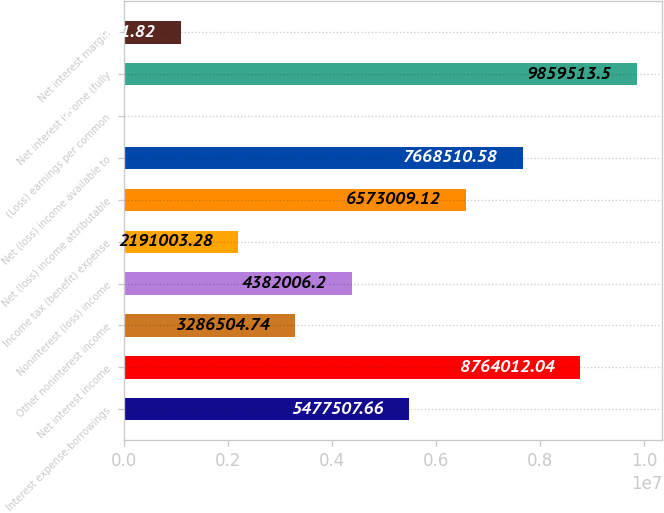<chart> <loc_0><loc_0><loc_500><loc_500><bar_chart><fcel>Interest expense-borrowings<fcel>Net interest income<fcel>Other noninterest income<fcel>Noninterest (loss) income<fcel>Income tax (benefit) expense<fcel>Net (loss) income attributable<fcel>Net (loss) income available to<fcel>(Loss) earnings per common<fcel>Net interest income (fully<fcel>Net interest margin<nl><fcel>5.47751e+06<fcel>8.76401e+06<fcel>3.2865e+06<fcel>4.38201e+06<fcel>2.191e+06<fcel>6.57301e+06<fcel>7.66851e+06<fcel>0.36<fcel>9.85951e+06<fcel>1.0955e+06<nl></chart> 